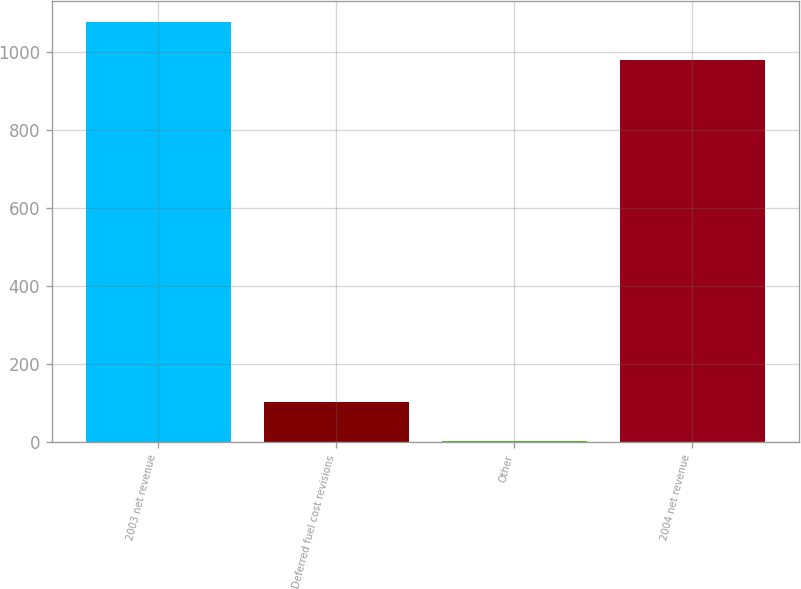Convert chart. <chart><loc_0><loc_0><loc_500><loc_500><bar_chart><fcel>2003 net revenue<fcel>Deferred fuel cost revisions<fcel>Other<fcel>2004 net revenue<nl><fcel>1077.93<fcel>102.93<fcel>3.4<fcel>978.4<nl></chart> 